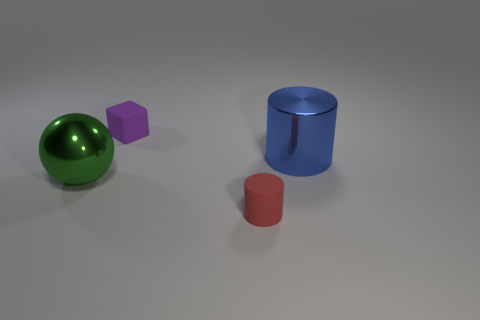There is a purple thing that is the same size as the red cylinder; what shape is it?
Your answer should be very brief. Cube. Is there any other thing that has the same shape as the tiny purple thing?
Provide a succinct answer. No. Is the color of the matte object in front of the big green metallic ball the same as the tiny matte object behind the large blue shiny cylinder?
Keep it short and to the point. No. How many matte objects are either big objects or cubes?
Your answer should be compact. 1. Is there any other thing that has the same size as the metal sphere?
Provide a succinct answer. Yes. What is the shape of the big metal thing to the left of the tiny rubber object in front of the large blue thing?
Your answer should be compact. Sphere. Is the material of the cylinder to the left of the large cylinder the same as the thing behind the blue shiny object?
Offer a terse response. Yes. There is a blue shiny thing behind the green shiny sphere; how many tiny rubber objects are on the right side of it?
Your response must be concise. 0. Does the tiny thing that is in front of the big metal cylinder have the same shape as the large object that is on the right side of the red cylinder?
Give a very brief answer. Yes. There is a object that is in front of the blue metallic thing and on the right side of the small block; what is its size?
Provide a short and direct response. Small. 